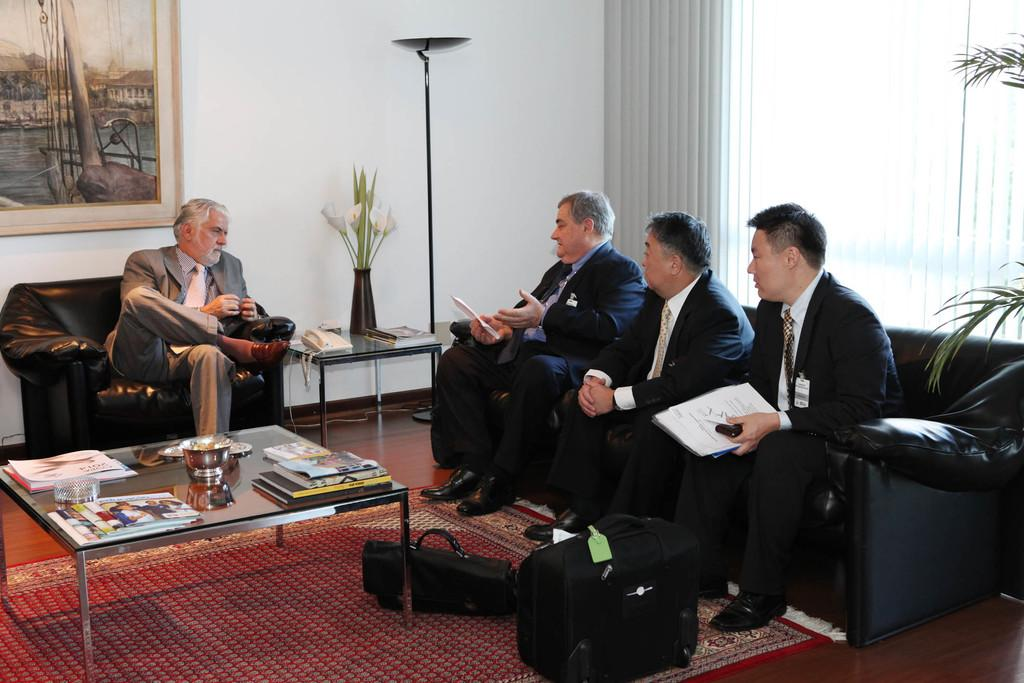What type of furniture can be seen in the image? There is a sofa and a chair in the image. What are the people sitting on in the image? The people are sitting on a sofa and a chair. What items are on the table in the image? There are books, paper, and a bowl on the table in the image. What rule is being discussed by the minister in the image? There is no minister or discussion of a rule present in the image. 